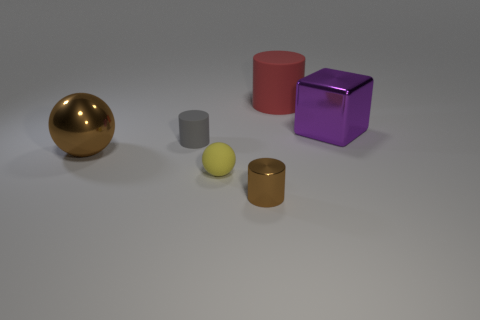Subtract all matte cylinders. How many cylinders are left? 1 Add 3 green objects. How many objects exist? 9 Subtract all brown spheres. How many spheres are left? 1 Subtract all cubes. How many objects are left? 5 Subtract 1 balls. How many balls are left? 1 Subtract all green blocks. Subtract all yellow spheres. How many blocks are left? 1 Subtract all brown spheres. How many red cylinders are left? 1 Subtract all small brown things. Subtract all red rubber things. How many objects are left? 4 Add 6 shiny objects. How many shiny objects are left? 9 Add 6 purple objects. How many purple objects exist? 7 